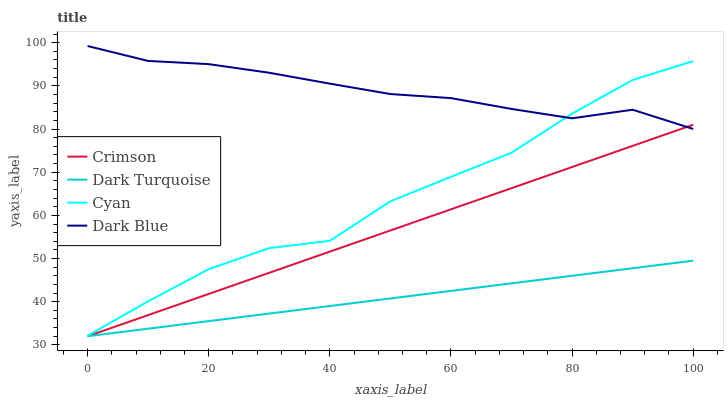Does Dark Turquoise have the minimum area under the curve?
Answer yes or no. Yes. Does Dark Blue have the maximum area under the curve?
Answer yes or no. Yes. Does Dark Blue have the minimum area under the curve?
Answer yes or no. No. Does Dark Turquoise have the maximum area under the curve?
Answer yes or no. No. Is Dark Turquoise the smoothest?
Answer yes or no. Yes. Is Cyan the roughest?
Answer yes or no. Yes. Is Dark Blue the smoothest?
Answer yes or no. No. Is Dark Blue the roughest?
Answer yes or no. No. Does Crimson have the lowest value?
Answer yes or no. Yes. Does Dark Blue have the lowest value?
Answer yes or no. No. Does Dark Blue have the highest value?
Answer yes or no. Yes. Does Dark Turquoise have the highest value?
Answer yes or no. No. Is Dark Turquoise less than Dark Blue?
Answer yes or no. Yes. Is Dark Blue greater than Dark Turquoise?
Answer yes or no. Yes. Does Crimson intersect Dark Turquoise?
Answer yes or no. Yes. Is Crimson less than Dark Turquoise?
Answer yes or no. No. Is Crimson greater than Dark Turquoise?
Answer yes or no. No. Does Dark Turquoise intersect Dark Blue?
Answer yes or no. No. 